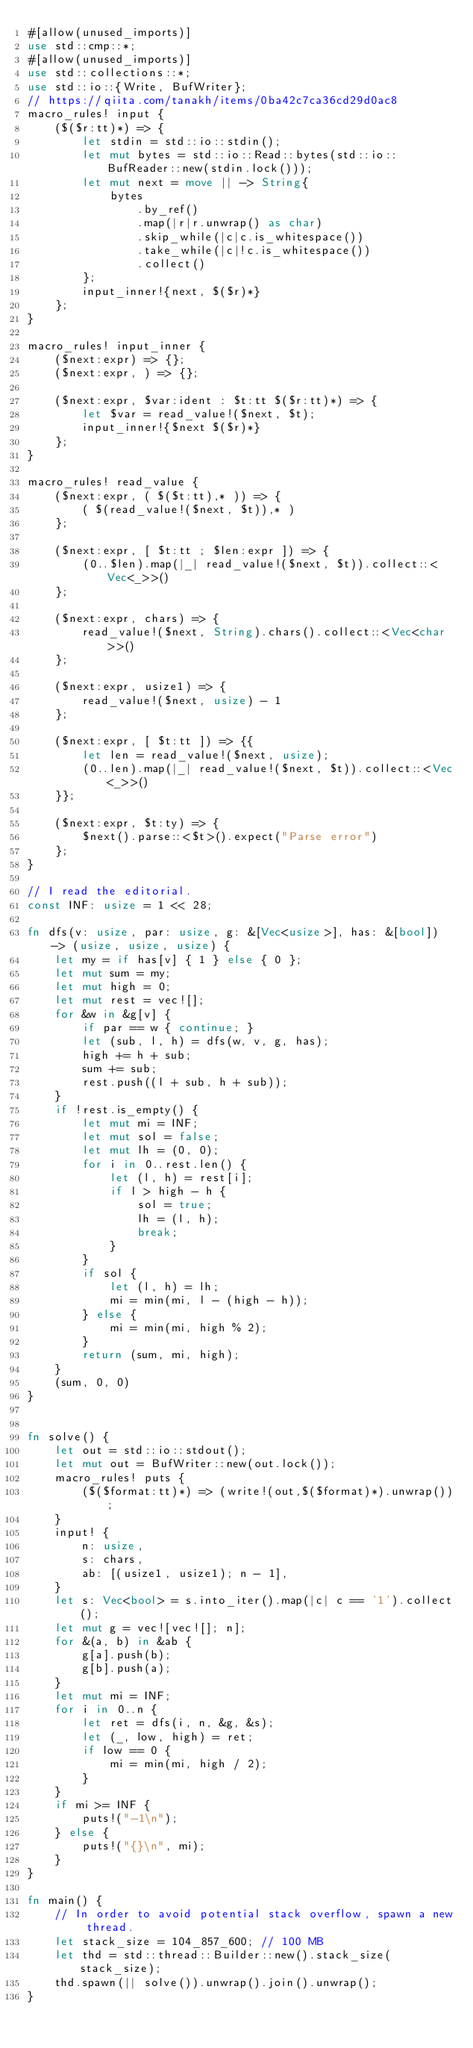<code> <loc_0><loc_0><loc_500><loc_500><_Rust_>#[allow(unused_imports)]
use std::cmp::*;
#[allow(unused_imports)]
use std::collections::*;
use std::io::{Write, BufWriter};
// https://qiita.com/tanakh/items/0ba42c7ca36cd29d0ac8
macro_rules! input {
    ($($r:tt)*) => {
        let stdin = std::io::stdin();
        let mut bytes = std::io::Read::bytes(std::io::BufReader::new(stdin.lock()));
        let mut next = move || -> String{
            bytes
                .by_ref()
                .map(|r|r.unwrap() as char)
                .skip_while(|c|c.is_whitespace())
                .take_while(|c|!c.is_whitespace())
                .collect()
        };
        input_inner!{next, $($r)*}
    };
}

macro_rules! input_inner {
    ($next:expr) => {};
    ($next:expr, ) => {};

    ($next:expr, $var:ident : $t:tt $($r:tt)*) => {
        let $var = read_value!($next, $t);
        input_inner!{$next $($r)*}
    };
}

macro_rules! read_value {
    ($next:expr, ( $($t:tt),* )) => {
        ( $(read_value!($next, $t)),* )
    };

    ($next:expr, [ $t:tt ; $len:expr ]) => {
        (0..$len).map(|_| read_value!($next, $t)).collect::<Vec<_>>()
    };

    ($next:expr, chars) => {
        read_value!($next, String).chars().collect::<Vec<char>>()
    };

    ($next:expr, usize1) => {
        read_value!($next, usize) - 1
    };

    ($next:expr, [ $t:tt ]) => {{
        let len = read_value!($next, usize);
        (0..len).map(|_| read_value!($next, $t)).collect::<Vec<_>>()
    }};

    ($next:expr, $t:ty) => {
        $next().parse::<$t>().expect("Parse error")
    };
}

// I read the editorial.
const INF: usize = 1 << 28;

fn dfs(v: usize, par: usize, g: &[Vec<usize>], has: &[bool]) -> (usize, usize, usize) {
    let my = if has[v] { 1 } else { 0 };
    let mut sum = my;
    let mut high = 0;
    let mut rest = vec![];
    for &w in &g[v] {
        if par == w { continue; }
        let (sub, l, h) = dfs(w, v, g, has);
        high += h + sub;
        sum += sub;
        rest.push((l + sub, h + sub));
    }
    if !rest.is_empty() {
        let mut mi = INF;
        let mut sol = false;
        let mut lh = (0, 0);
        for i in 0..rest.len() {
            let (l, h) = rest[i];
            if l > high - h {
                sol = true;
                lh = (l, h);
                break;
            }
        }
        if sol {
            let (l, h) = lh;
            mi = min(mi, l - (high - h));
        } else {
            mi = min(mi, high % 2);
        }
        return (sum, mi, high);
    }
    (sum, 0, 0)
}


fn solve() {
    let out = std::io::stdout();
    let mut out = BufWriter::new(out.lock());
    macro_rules! puts {
        ($($format:tt)*) => (write!(out,$($format)*).unwrap());
    }
    input! {
        n: usize,
        s: chars,
        ab: [(usize1, usize1); n - 1],
    }
    let s: Vec<bool> = s.into_iter().map(|c| c == '1').collect();
    let mut g = vec![vec![]; n];
    for &(a, b) in &ab {
        g[a].push(b);
        g[b].push(a);
    }
    let mut mi = INF;
    for i in 0..n {
        let ret = dfs(i, n, &g, &s);
        let (_, low, high) = ret;
        if low == 0 {
            mi = min(mi, high / 2);
        }
    }
    if mi >= INF {
        puts!("-1\n");
    } else {
        puts!("{}\n", mi);
    }
}

fn main() {
    // In order to avoid potential stack overflow, spawn a new thread.
    let stack_size = 104_857_600; // 100 MB
    let thd = std::thread::Builder::new().stack_size(stack_size);
    thd.spawn(|| solve()).unwrap().join().unwrap();
}
</code> 